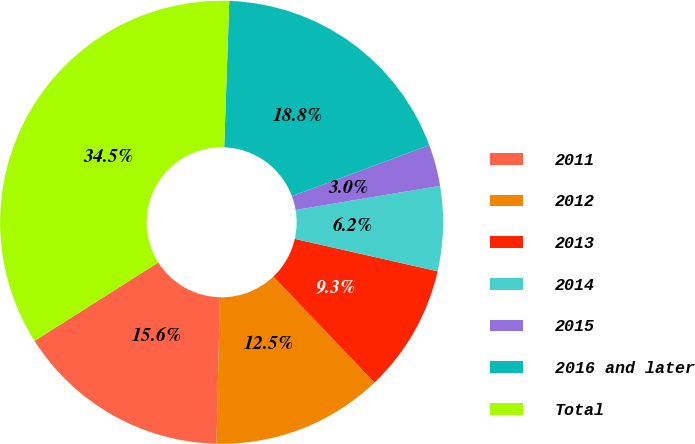Convert chart. <chart><loc_0><loc_0><loc_500><loc_500><pie_chart><fcel>2011<fcel>2012<fcel>2013<fcel>2014<fcel>2015<fcel>2016 and later<fcel>Total<nl><fcel>15.64%<fcel>12.49%<fcel>9.33%<fcel>6.18%<fcel>3.03%<fcel>18.79%<fcel>34.54%<nl></chart> 